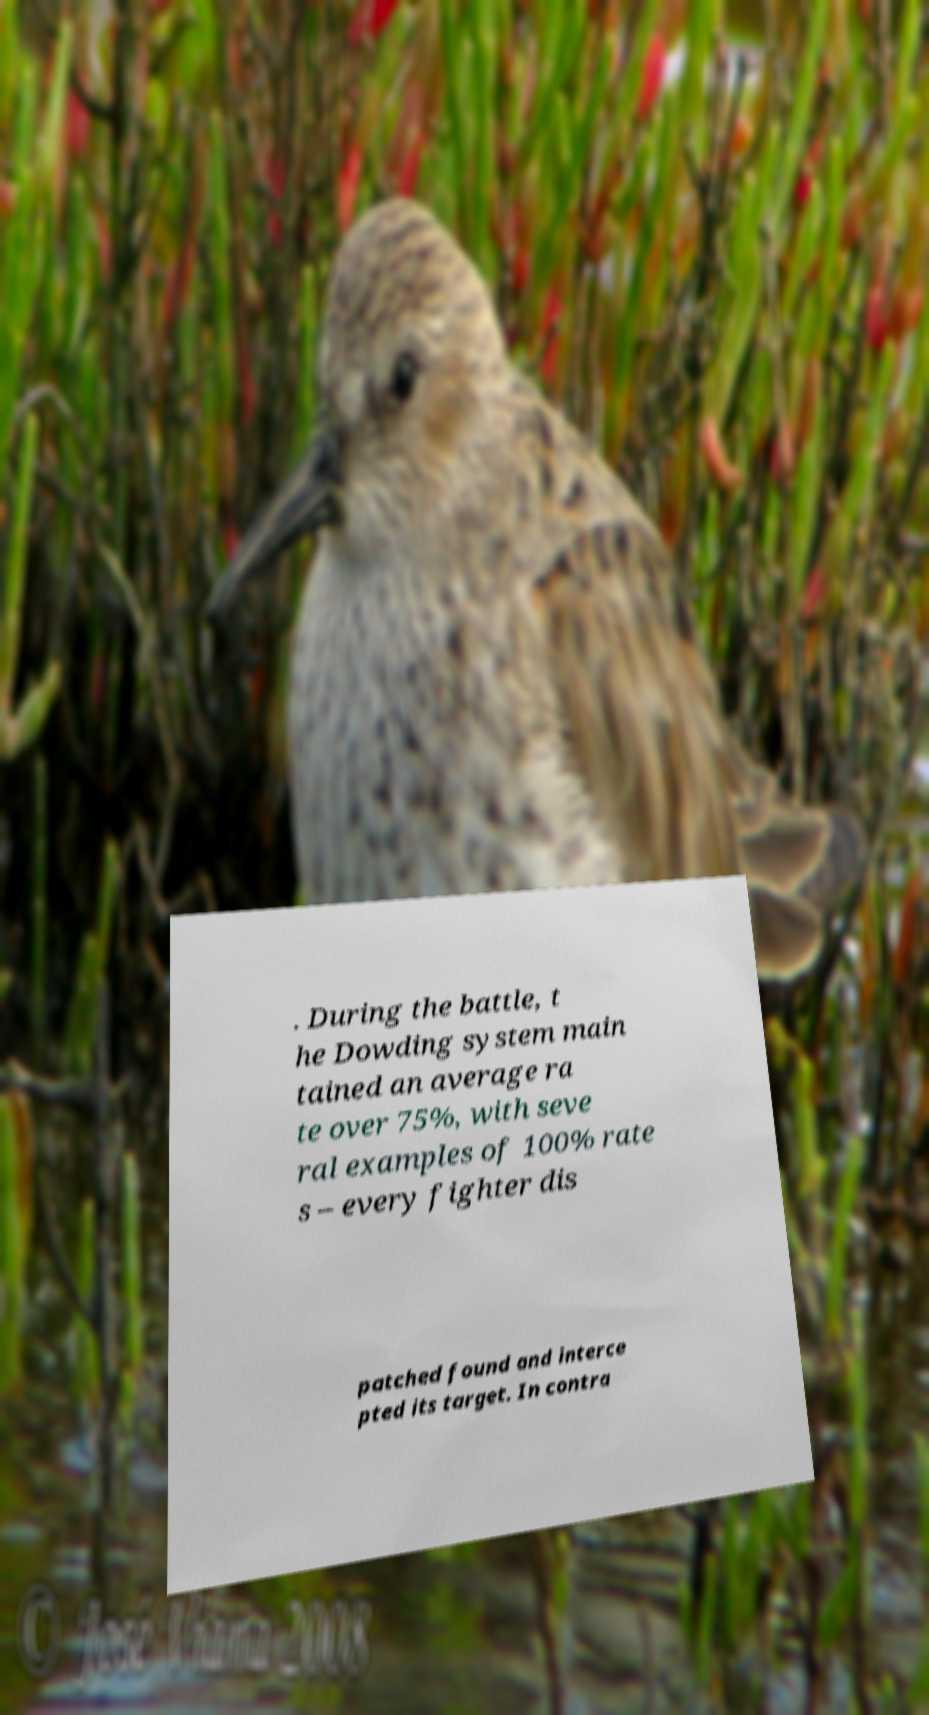Please read and relay the text visible in this image. What does it say? . During the battle, t he Dowding system main tained an average ra te over 75%, with seve ral examples of 100% rate s – every fighter dis patched found and interce pted its target. In contra 